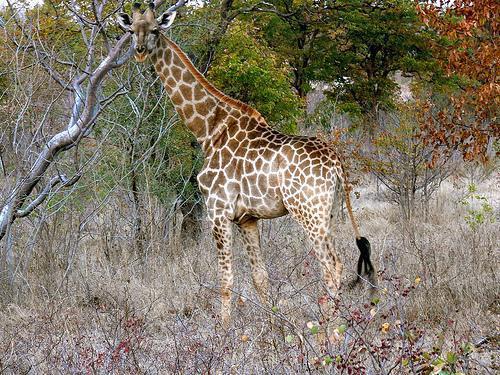How many giraffes?
Give a very brief answer. 1. 